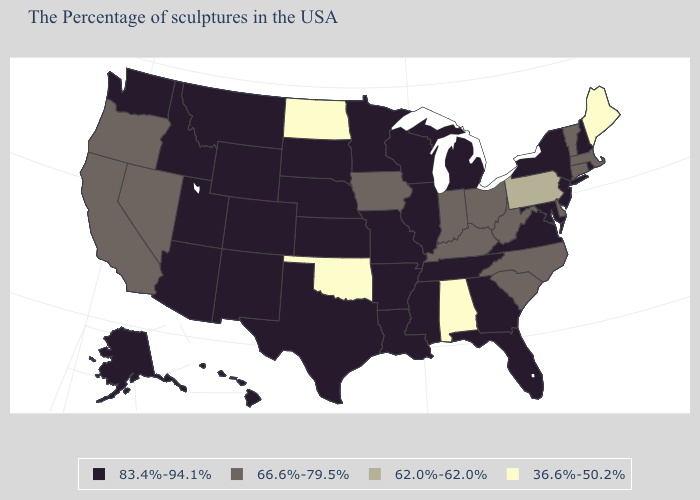Does Oklahoma have the lowest value in the South?
Give a very brief answer. Yes. Name the states that have a value in the range 36.6%-50.2%?
Short answer required. Maine, Alabama, Oklahoma, North Dakota. What is the value of Iowa?
Quick response, please. 66.6%-79.5%. Name the states that have a value in the range 62.0%-62.0%?
Answer briefly. Pennsylvania. What is the value of North Dakota?
Be succinct. 36.6%-50.2%. What is the lowest value in states that border Montana?
Give a very brief answer. 36.6%-50.2%. How many symbols are there in the legend?
Concise answer only. 4. Name the states that have a value in the range 83.4%-94.1%?
Quick response, please. Rhode Island, New Hampshire, New York, New Jersey, Maryland, Virginia, Florida, Georgia, Michigan, Tennessee, Wisconsin, Illinois, Mississippi, Louisiana, Missouri, Arkansas, Minnesota, Kansas, Nebraska, Texas, South Dakota, Wyoming, Colorado, New Mexico, Utah, Montana, Arizona, Idaho, Washington, Alaska, Hawaii. Does Alabama have a lower value than North Dakota?
Give a very brief answer. No. What is the value of Connecticut?
Short answer required. 66.6%-79.5%. Name the states that have a value in the range 66.6%-79.5%?
Concise answer only. Massachusetts, Vermont, Connecticut, Delaware, North Carolina, South Carolina, West Virginia, Ohio, Kentucky, Indiana, Iowa, Nevada, California, Oregon. What is the highest value in the MidWest ?
Short answer required. 83.4%-94.1%. Name the states that have a value in the range 62.0%-62.0%?
Quick response, please. Pennsylvania. What is the value of Texas?
Short answer required. 83.4%-94.1%. What is the value of Alabama?
Write a very short answer. 36.6%-50.2%. 